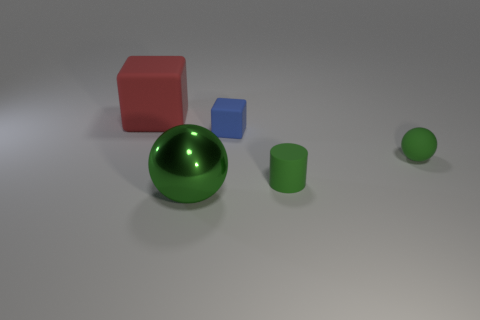How many green things are spheres or big matte objects?
Ensure brevity in your answer.  2. Is the number of blue cubes that are to the left of the green shiny sphere greater than the number of balls?
Offer a very short reply. No. Does the blue cube have the same size as the red rubber object?
Provide a succinct answer. No. What is the color of the other cube that is the same material as the blue cube?
Your answer should be compact. Red. What is the shape of the large metal object that is the same color as the small cylinder?
Offer a very short reply. Sphere. Are there an equal number of metal spheres right of the small sphere and small rubber balls that are in front of the tiny rubber cylinder?
Your response must be concise. Yes. The rubber object that is on the left side of the tiny matte object behind the small ball is what shape?
Ensure brevity in your answer.  Cube. There is a large red thing that is the same shape as the blue matte thing; what material is it?
Your answer should be compact. Rubber. What color is the matte sphere that is the same size as the cylinder?
Offer a terse response. Green. Are there an equal number of tiny green cylinders that are on the right side of the green matte sphere and red matte objects?
Offer a very short reply. No. 